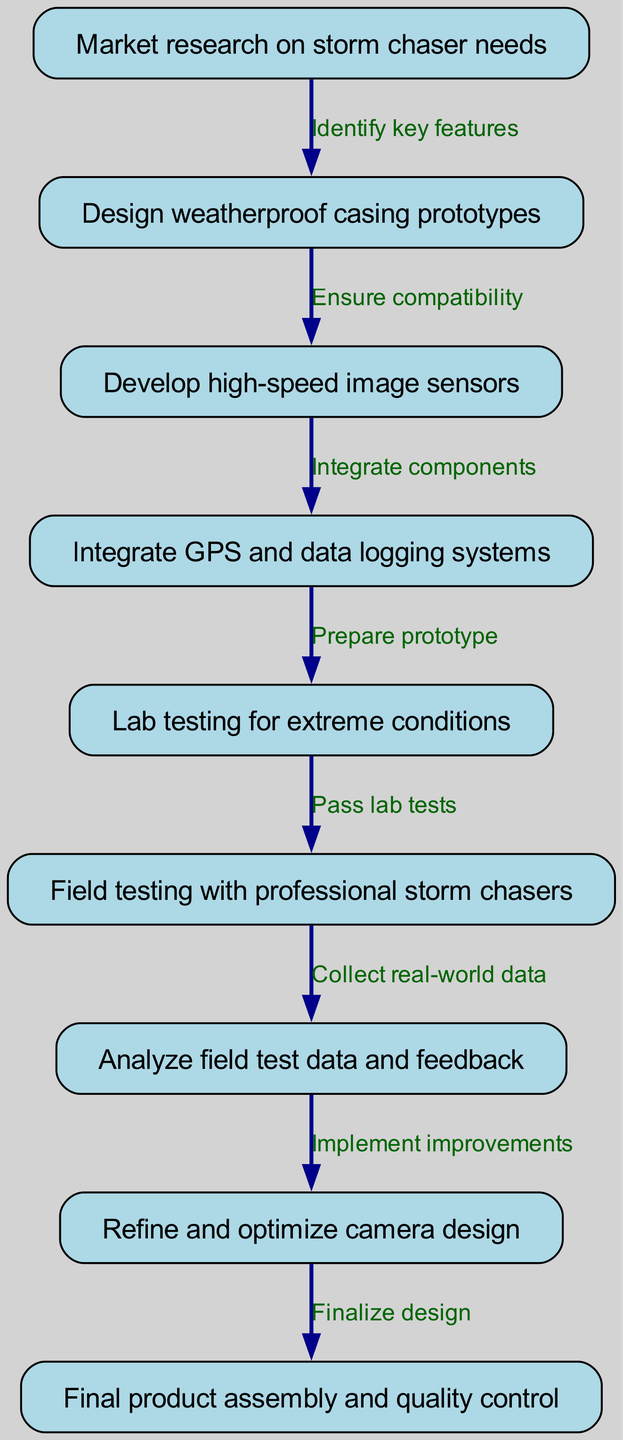What is the first step in the clinical pathway? The first step is "Market research on storm chaser needs," which is represented as node 1 in the diagram.
Answer: Market research on storm chaser needs How many nodes are there in total? To determine the total number of nodes, we count each individual node listed in the data, which totals nine distinct nodes.
Answer: 9 What relationship exists between node 2 and node 3? Node 2, "Design weatherproof casing prototypes," leads to node 3, "Develop high-speed image sensors," through the edge labeled "Ensure compatibility."
Answer: Ensure compatibility Which step comes after field testing? After field testing, which is node 6, the next step is to analyze the field test data and feedback, represented by node 7.
Answer: Analyze field test data and feedback What is the last step of the clinical pathway? The last step is represented by node 9, which is "Final product assembly and quality control." This is the final output of the process.
Answer: Final product assembly and quality control What must happen before product assembly? Before product assembly, the design must be refined and optimized, indicated by node 8. This step occurs directly before assembly.
Answer: Refine and optimize camera design How do the lab tests relate to field testing? The lab tests, conducted in node 5, must pass successfully before proceeding to field testing, which is node 6. Thus, the relationship is sequential; field testing can only happen after lab tests pass.
Answer: Pass lab tests What is the step directly linked to analyzing feedback? The step directly linked to analyzing feedback is refining and optimizing the camera design, represented as node 8, making it the next action following the analysis.
Answer: Refine and optimize camera design 